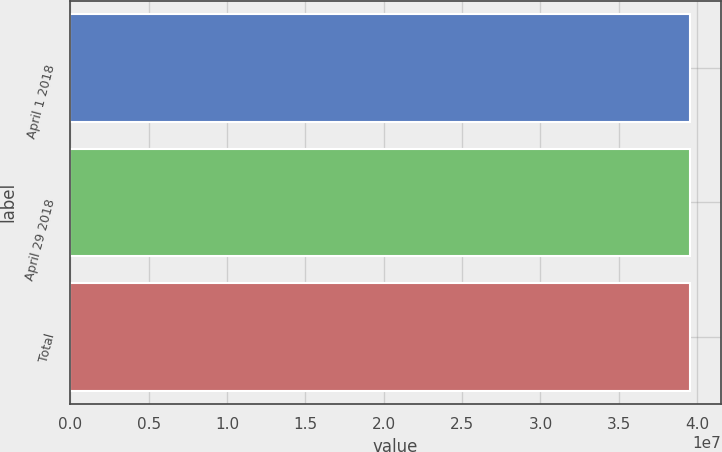<chart> <loc_0><loc_0><loc_500><loc_500><bar_chart><fcel>April 1 2018<fcel>April 29 2018<fcel>Total<nl><fcel>3.9525e+07<fcel>3.95156e+07<fcel>3.95165e+07<nl></chart> 